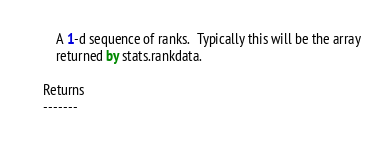Convert code to text. <code><loc_0><loc_0><loc_500><loc_500><_Cython_>        A 1-d sequence of ranks.  Typically this will be the array
        returned by stats.rankdata.

    Returns
    -------</code> 